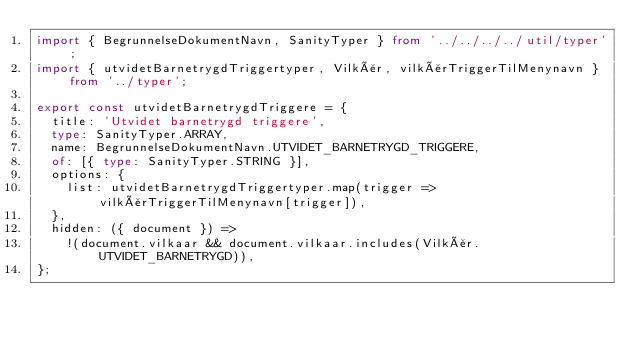Convert code to text. <code><loc_0><loc_0><loc_500><loc_500><_TypeScript_>import { BegrunnelseDokumentNavn, SanityTyper } from '../../../../util/typer';
import { utvidetBarnetrygdTriggertyper, Vilkår, vilkårTriggerTilMenynavn } from '../typer';

export const utvidetBarnetrygdTriggere = {
  title: 'Utvidet barnetrygd triggere',
  type: SanityTyper.ARRAY,
  name: BegrunnelseDokumentNavn.UTVIDET_BARNETRYGD_TRIGGERE,
  of: [{ type: SanityTyper.STRING }],
  options: {
    list: utvidetBarnetrygdTriggertyper.map(trigger => vilkårTriggerTilMenynavn[trigger]),
  },
  hidden: ({ document }) =>
    !(document.vilkaar && document.vilkaar.includes(Vilkår.UTVIDET_BARNETRYGD)),
};
</code> 